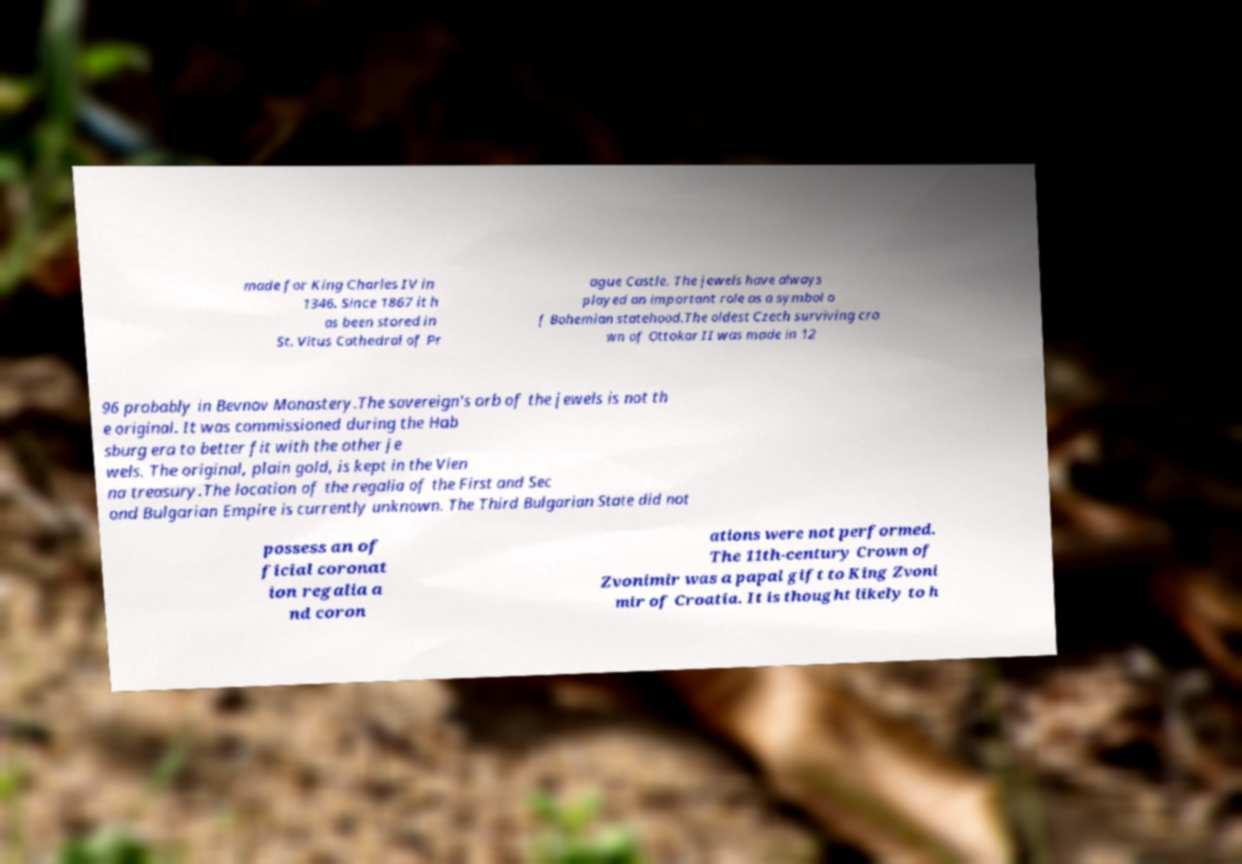There's text embedded in this image that I need extracted. Can you transcribe it verbatim? made for King Charles IV in 1346. Since 1867 it h as been stored in St. Vitus Cathedral of Pr ague Castle. The jewels have always played an important role as a symbol o f Bohemian statehood.The oldest Czech surviving cro wn of Ottokar II was made in 12 96 probably in Bevnov Monastery.The sovereign's orb of the jewels is not th e original. It was commissioned during the Hab sburg era to better fit with the other je wels. The original, plain gold, is kept in the Vien na treasury.The location of the regalia of the First and Sec ond Bulgarian Empire is currently unknown. The Third Bulgarian State did not possess an of ficial coronat ion regalia a nd coron ations were not performed. The 11th-century Crown of Zvonimir was a papal gift to King Zvoni mir of Croatia. It is thought likely to h 